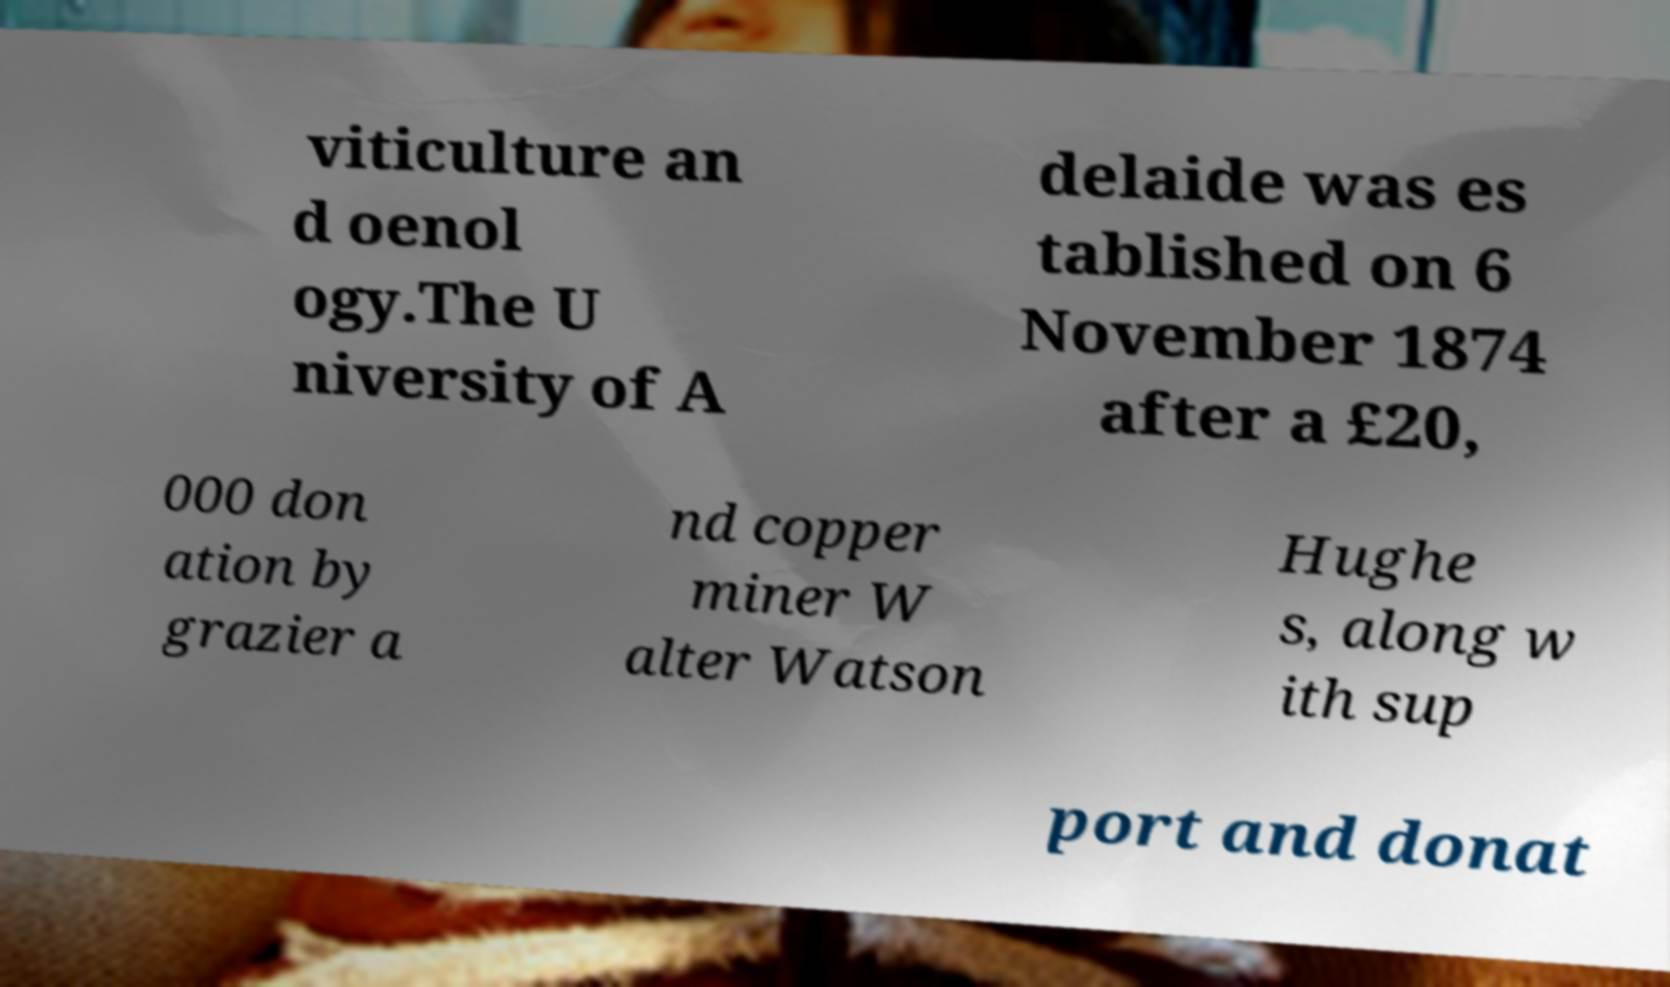Please identify and transcribe the text found in this image. viticulture an d oenol ogy.The U niversity of A delaide was es tablished on 6 November 1874 after a £20, 000 don ation by grazier a nd copper miner W alter Watson Hughe s, along w ith sup port and donat 